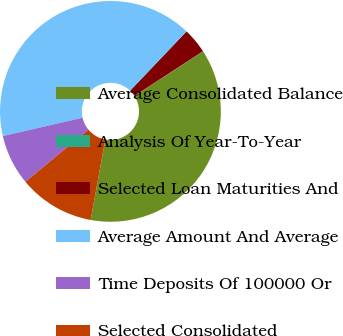<chart> <loc_0><loc_0><loc_500><loc_500><pie_chart><fcel>Average Consolidated Balance<fcel>Analysis Of Year-To-Year<fcel>Selected Loan Maturities And<fcel>Average Amount And Average<fcel>Time Deposits Of 100000 Or<fcel>Selected Consolidated<nl><fcel>36.99%<fcel>0.04%<fcel>3.73%<fcel>40.69%<fcel>7.43%<fcel>11.12%<nl></chart> 